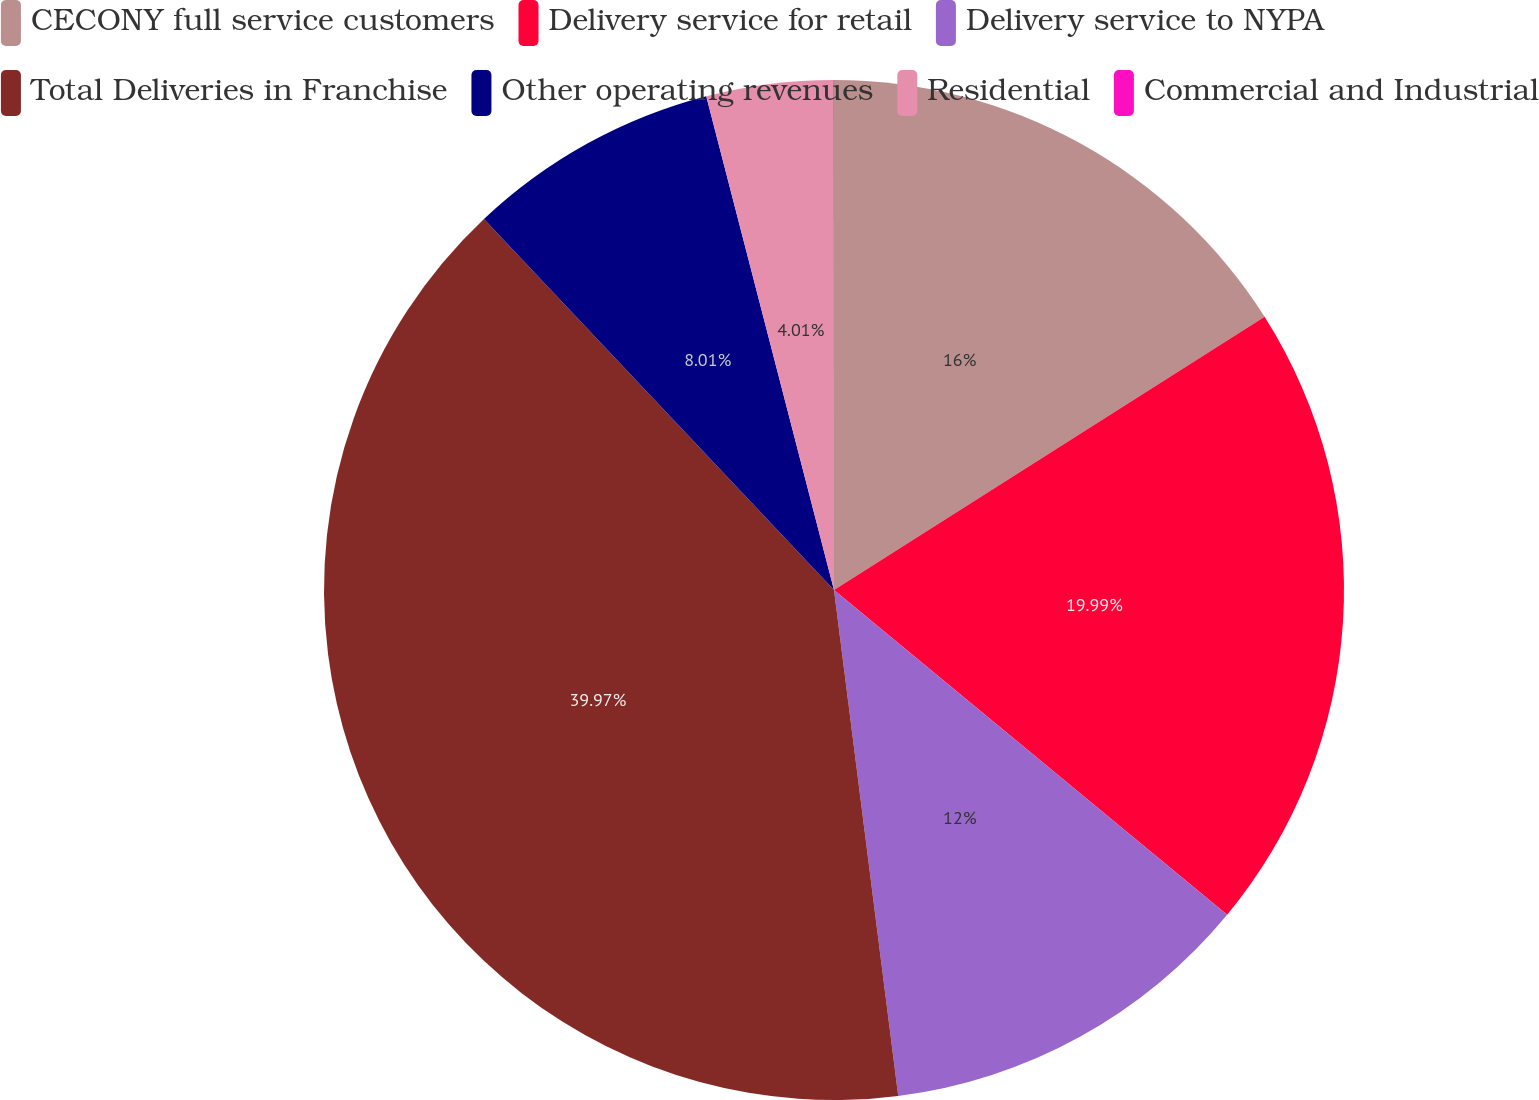Convert chart. <chart><loc_0><loc_0><loc_500><loc_500><pie_chart><fcel>CECONY full service customers<fcel>Delivery service for retail<fcel>Delivery service to NYPA<fcel>Total Deliveries in Franchise<fcel>Other operating revenues<fcel>Residential<fcel>Commercial and Industrial<nl><fcel>16.0%<fcel>19.99%<fcel>12.0%<fcel>39.97%<fcel>8.01%<fcel>4.01%<fcel>0.02%<nl></chart> 